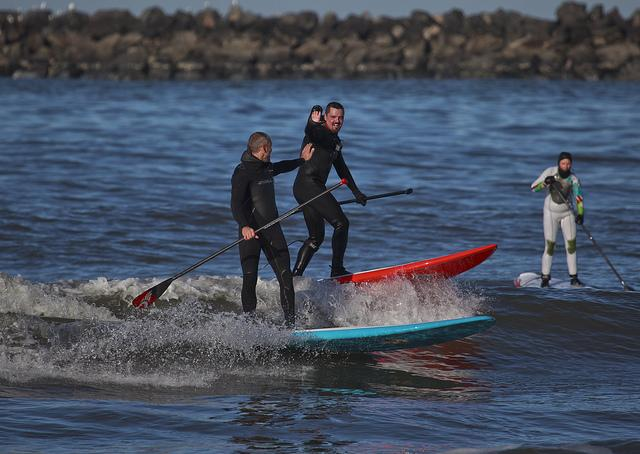Which artist depicted Polynesians practicing this sport on the Sandwich Islands? Please explain your reasoning. john webber. The artist was webber. 